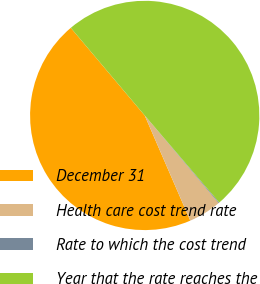Convert chart. <chart><loc_0><loc_0><loc_500><loc_500><pie_chart><fcel>December 31<fcel>Health care cost trend rate<fcel>Rate to which the cost trend<fcel>Year that the rate reaches the<nl><fcel>45.35%<fcel>4.65%<fcel>0.11%<fcel>49.89%<nl></chart> 